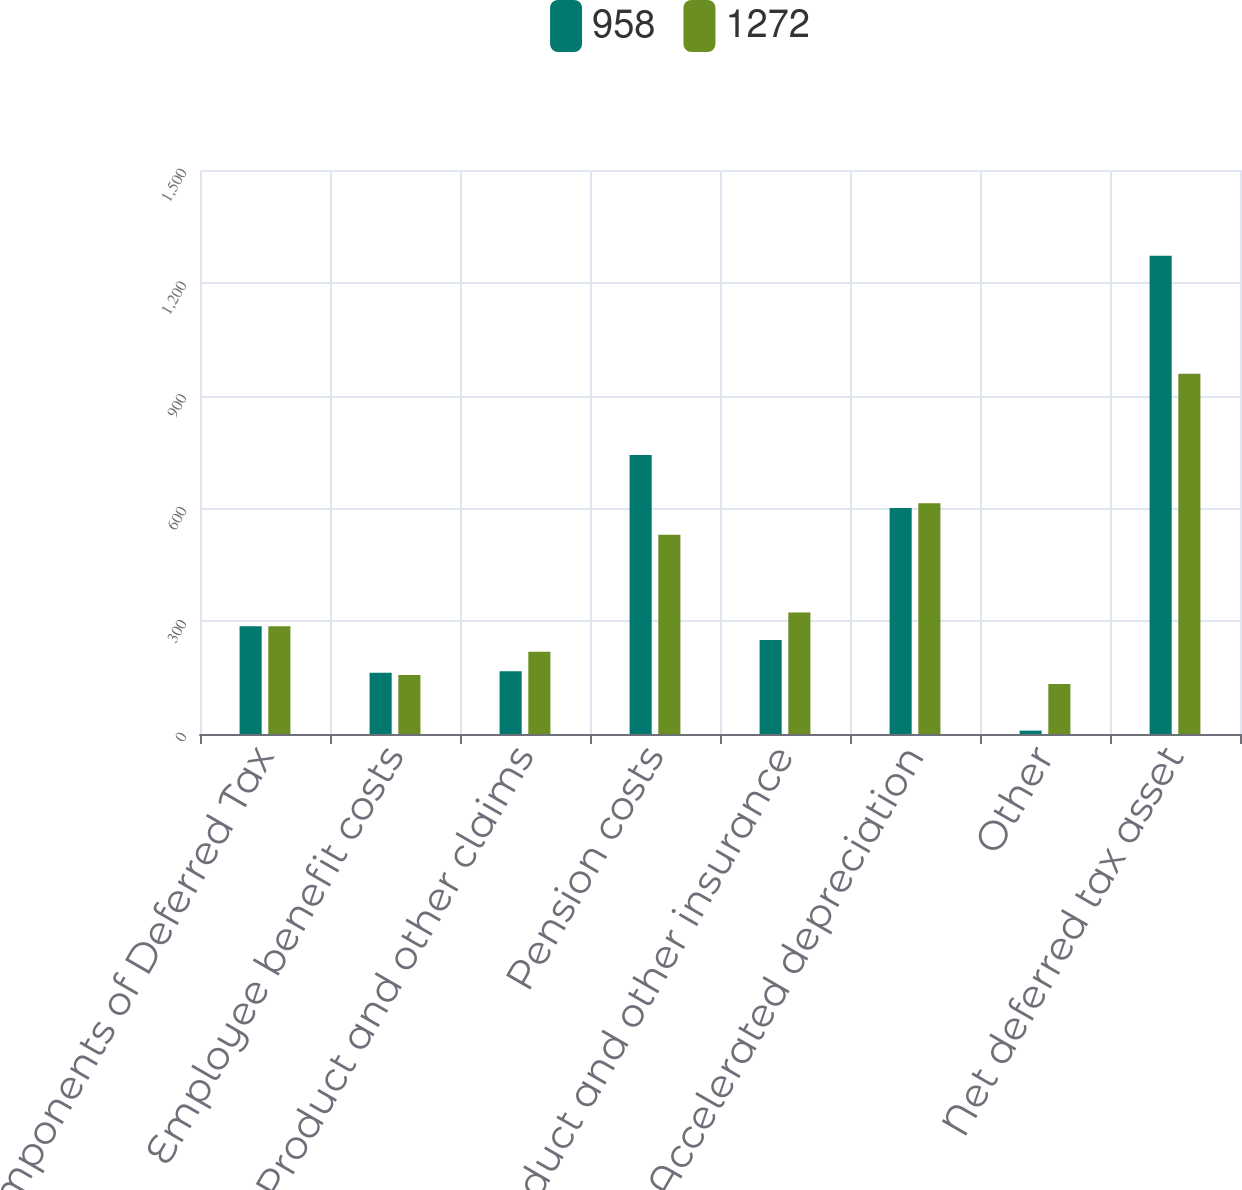Convert chart. <chart><loc_0><loc_0><loc_500><loc_500><stacked_bar_chart><ecel><fcel>Components of Deferred Tax<fcel>Employee benefit costs<fcel>Product and other claims<fcel>Pension costs<fcel>Product and other insurance<fcel>Accelerated depreciation<fcel>Other<fcel>Net deferred tax asset<nl><fcel>958<fcel>286.5<fcel>163<fcel>167<fcel>742<fcel>250<fcel>601<fcel>9<fcel>1272<nl><fcel>1272<fcel>286.5<fcel>157<fcel>219<fcel>530<fcel>323<fcel>614<fcel>133<fcel>958<nl></chart> 